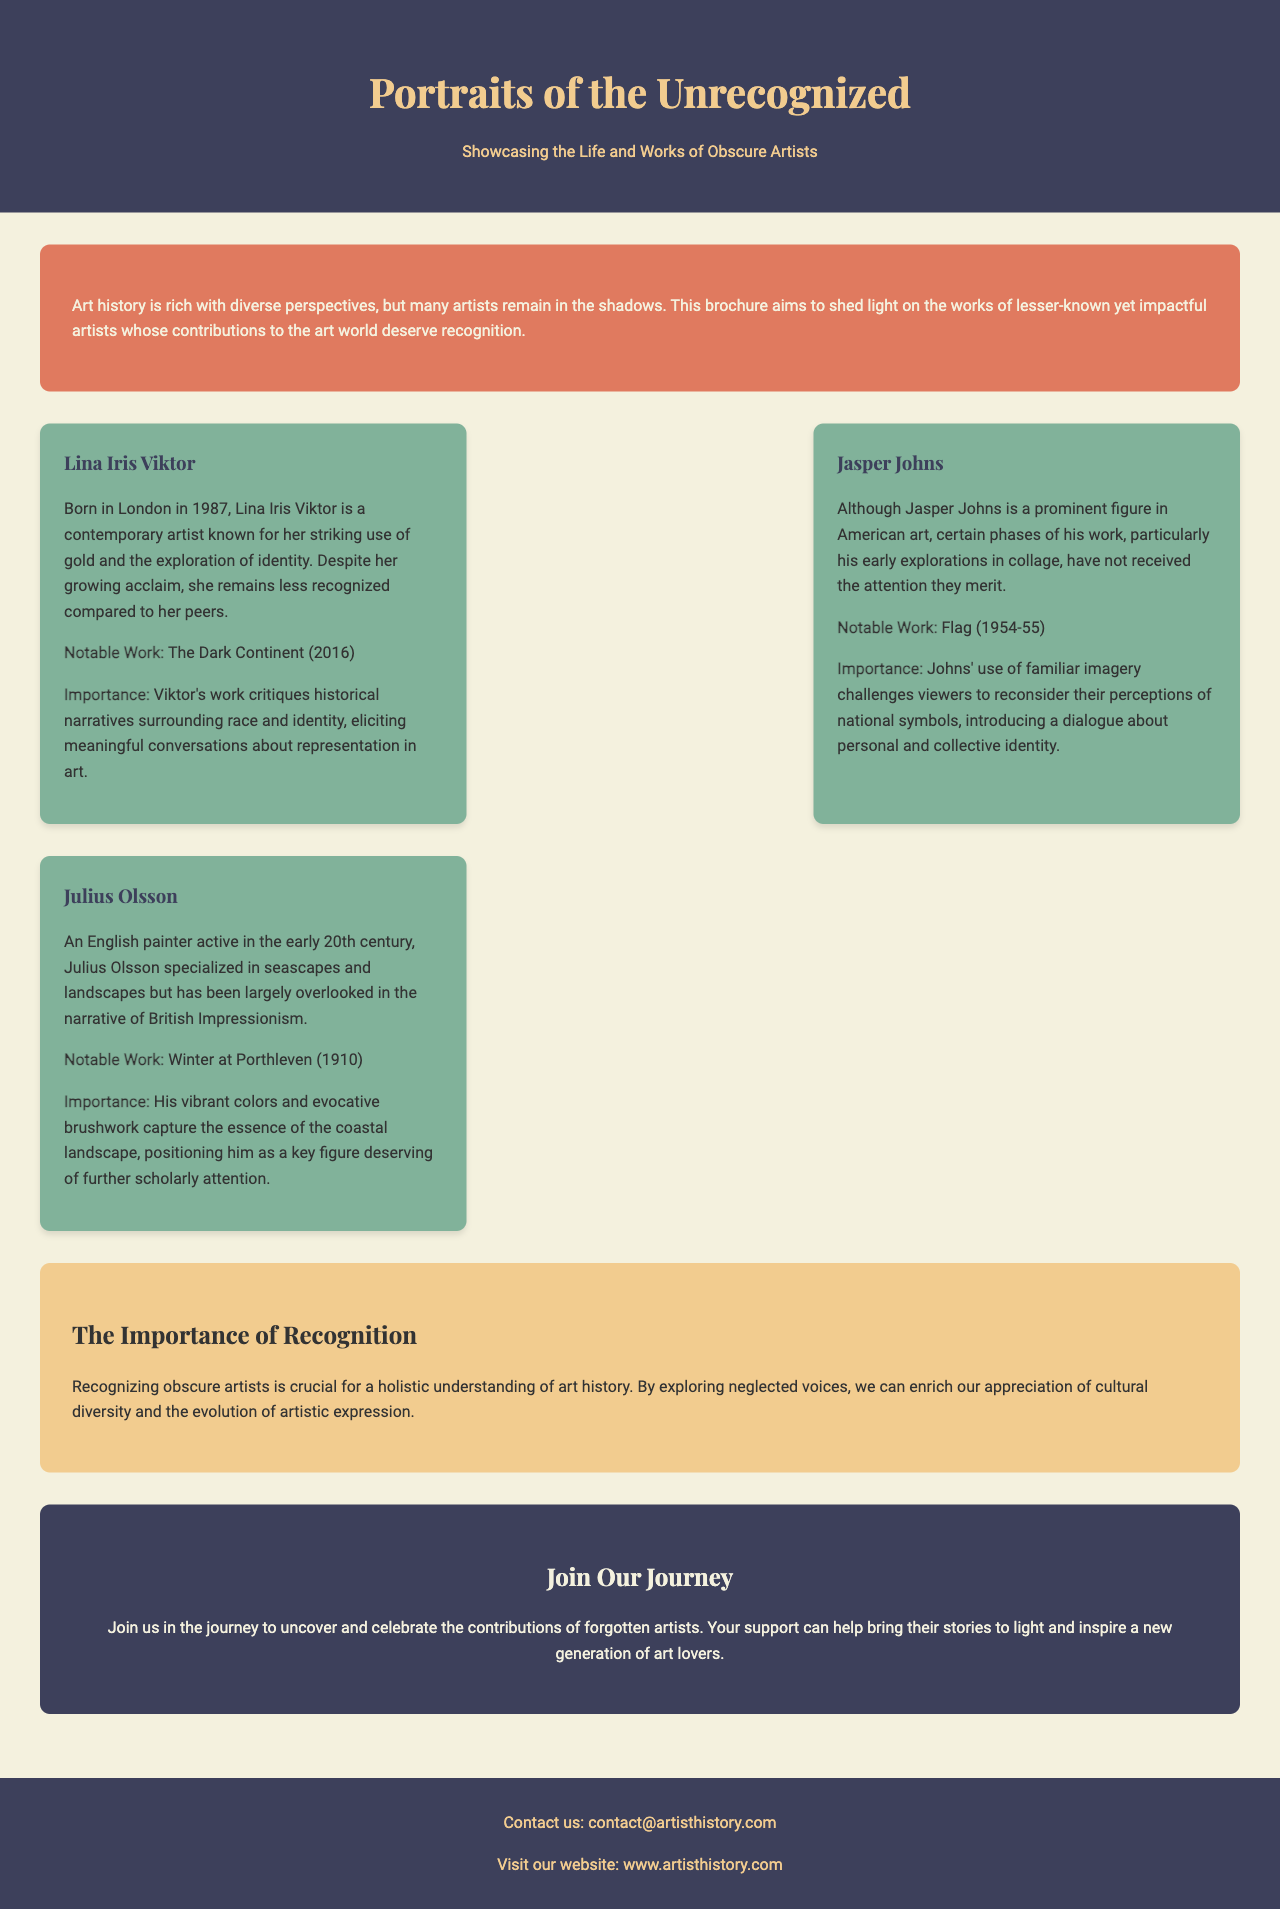What is the main theme of the brochure? The main theme of the brochure is to showcase the works of lesser-known artists and their contributions to art history.
Answer: Showcasing the Life and Works of Obscure Artists Who is the contemporary artist mentioned in the brochure? The brochure mentions Lina Iris Viktor as a contemporary artist.
Answer: Lina Iris Viktor What notable work is associated with Julius Olsson? The notable work associated with Julius Olsson mentioned in the brochure is "Winter at Porthleven."
Answer: Winter at Porthleven In what year was "The Dark Continent" created? The brochure states that "The Dark Continent" was created in 2016.
Answer: 2016 What color is the background of the "Importance of Recognition" section? The background color of the "Importance of Recognition" section is #f2cc8f.
Answer: #f2cc8f What does the brochure suggest contributes to a holistic understanding of art history? The brochure suggests that recognizing obscure artists contributes to a holistic understanding of art history.
Answer: Recognizing obscure artists How many artists are highlighted in the brochure? The brochure highlights three artists.
Answer: Three artists What action does the brochure encourage readers to take? The brochure encourages readers to join in celebrating forgotten artists.
Answer: Join Our Journey 